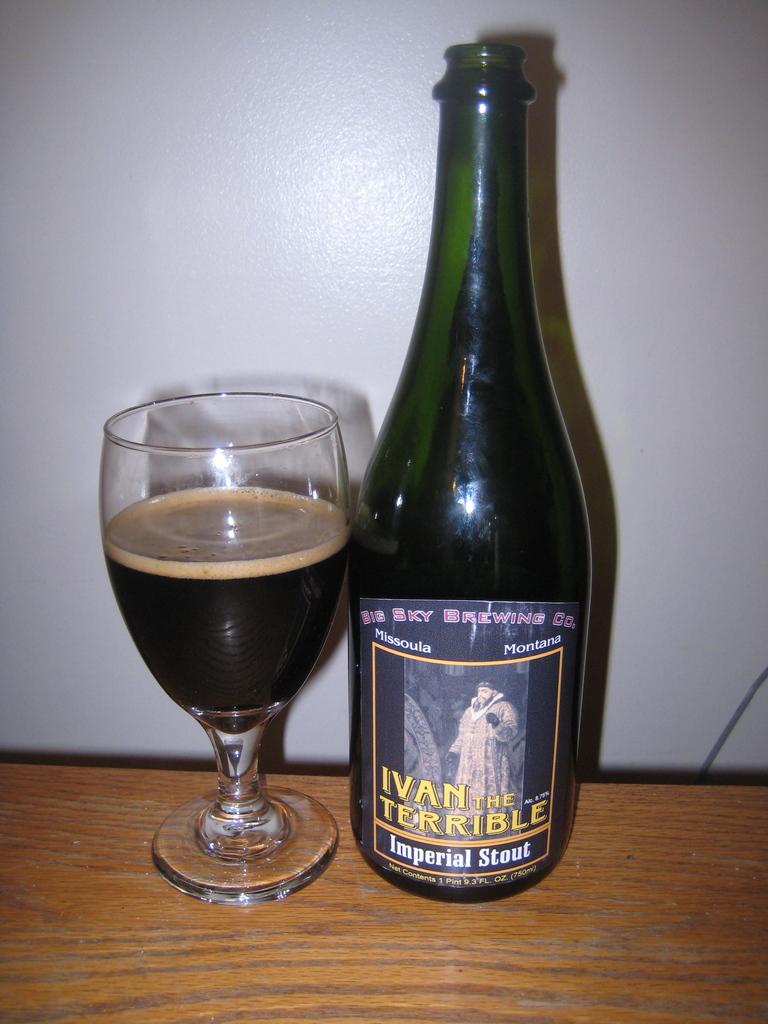What is the name of the wine?
Provide a succinct answer. Ivan the terrible. Which company made the beer?
Offer a very short reply. Big sky brewing. 